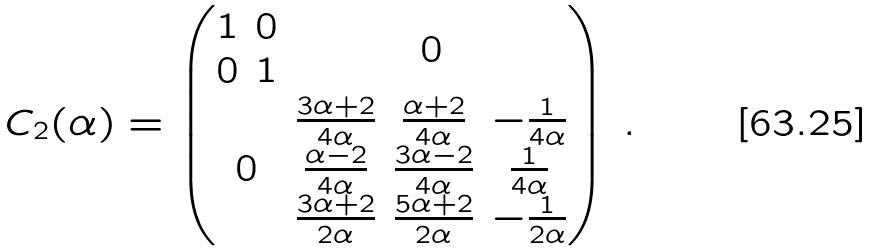<formula> <loc_0><loc_0><loc_500><loc_500>C _ { 2 } ( \alpha ) = \begin{pmatrix} \begin{matrix} 1 & 0 \\ 0 & 1 \end{matrix} & 0 \\ 0 & \begin{matrix} \frac { 3 \alpha + 2 } { 4 \alpha } & \frac { \alpha + 2 } { 4 \alpha } & - \frac { 1 } { 4 \alpha } \\ \frac { \alpha - 2 } { 4 \alpha } & \frac { 3 \alpha - 2 } { 4 \alpha } & \frac { 1 } { 4 \alpha } \\ \frac { 3 \alpha + 2 } { 2 \alpha } & \frac { 5 \alpha + 2 } { 2 \alpha } & - \frac { 1 } { 2 \alpha } \end{matrix} \end{pmatrix} \, .</formula> 